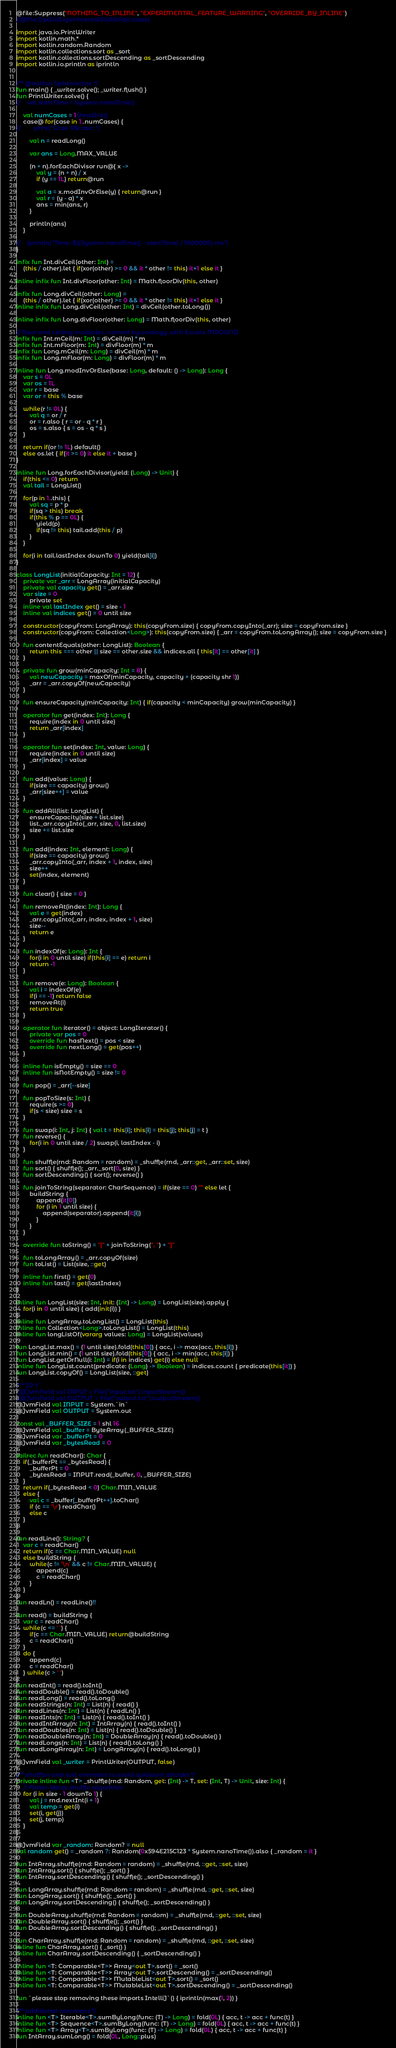Convert code to text. <code><loc_0><loc_0><loc_500><loc_500><_Kotlin_>@file:Suppress("NOTHING_TO_INLINE", "EXPERIMENTAL_FEATURE_WARNING", "OVERRIDE_BY_INLINE")
//@file:OptIn(ExperimentalStdlibApi::class)

import java.io.PrintWriter
import kotlin.math.*
import kotlin.random.Random
import kotlin.collections.sort as _sort
import kotlin.collections.sortDescending as _sortDescending
import kotlin.io.println as iprintln


/** @author Spheniscine */
fun main() { _writer.solve(); _writer.flush() }
fun PrintWriter.solve() {
//    val startTime = System.nanoTime()

    val numCases = 1//readInt()
    case@ for(case in 1..numCases) {
//        print("Case #$case: ")

        val n = readLong()

        var ans = Long.MAX_VALUE

        (n + n).forEachDivisor run@{ x ->
            val y = (n + n) / x
            if (y == 1L) return@run

            val a = x.modInvOrElse(y) { return@run }
            val r = (y - a) * x
            ans = min(ans, r)
        }

        println(ans)
    }

//    iprintln("Time: ${(System.nanoTime() - startTime) / 1000000} ms")
}

infix fun Int.divCeil(other: Int) =
    (this / other).let { if(xor(other) >= 0 && it * other != this) it+1 else it }

inline infix fun Int.divFloor(other: Int) = Math.floorDiv(this, other)

infix fun Long.divCeil(other: Long) =
    (this / other).let { if(xor(other) >= 0 && it * other != this) it+1 else it }
inline infix fun Long.divCeil(other: Int) = divCeil(other.toLong())

inline infix fun Long.divFloor(other: Long) = Math.floorDiv(this, other)

// floor and ceiling multiples, named by analogy with Excel's MROUND
infix fun Int.mCeil(m: Int) = divCeil(m) * m
infix fun Int.mFloor(m: Int) = divFloor(m) * m
infix fun Long.mCeil(m: Long) = divCeil(m) * m
infix fun Long.mFloor(m: Long) = divFloor(m) * m

inline fun Long.modInvOrElse(base: Long, default: () -> Long): Long {
    var s = 0L
    var os = 1L
    var r = base
    var or = this % base

    while(r != 0L) {
        val q = or / r
        or = r.also { r = or - q * r }
        os = s.also { s = os - q * s }
    }

    return if(or != 1L) default()
    else os.let { if(it >= 0) it else it + base }
}

inline fun Long.forEachDivisor(yield: (Long) -> Unit) {
    if(this <= 0) return
    val tail = LongList()

    for(p in 1..this) {
        val sq = p * p
        if(sq > this) break
        if(this % p == 0L) {
            yield(p)
            if(sq != this) tail.add(this / p)
        }
    }

    for(i in tail.lastIndex downTo 0) yield(tail[i])
}

class LongList(initialCapacity: Int = 12) {
    private var _arr = LongArray(initialCapacity)
    private val capacity get() = _arr.size
    var size = 0
        private set
    inline val lastIndex get() = size - 1
    inline val indices get() = 0 until size

    constructor(copyFrom: LongArray): this(copyFrom.size) { copyFrom.copyInto(_arr); size = copyFrom.size }
    constructor(copyFrom: Collection<Long>): this(copyFrom.size) { _arr = copyFrom.toLongArray(); size = copyFrom.size }

    fun contentEquals(other: LongList): Boolean {
        return this === other || size == other.size && indices.all { this[it] == other[it] }
    }

    private fun grow(minCapacity: Int = 8) {
        val newCapacity = maxOf(minCapacity, capacity + (capacity shr 1))
        _arr = _arr.copyOf(newCapacity)
    }

    fun ensureCapacity(minCapacity: Int) { if(capacity < minCapacity) grow(minCapacity) }

    operator fun get(index: Int): Long {
        require(index in 0 until size)
        return _arr[index]
    }

    operator fun set(index: Int, value: Long) {
        require(index in 0 until size)
        _arr[index] = value
    }

    fun add(value: Long) {
        if(size == capacity) grow()
        _arr[size++] = value
    }

    fun addAll(list: LongList) {
        ensureCapacity(size + list.size)
        list._arr.copyInto(_arr, size, 0, list.size)
        size += list.size
    }

    fun add(index: Int, element: Long) {
        if(size == capacity) grow()
        _arr.copyInto(_arr, index + 1, index, size)
        size++
        set(index, element)
    }

    fun clear() { size = 0 }

    fun removeAt(index: Int): Long {
        val e = get(index)
        _arr.copyInto(_arr, index, index + 1, size)
        size--
        return e
    }

    fun indexOf(e: Long): Int {
        for(i in 0 until size) if(this[i] == e) return i
        return -1
    }

    fun remove(e: Long): Boolean {
        val i = indexOf(e)
        if(i == -1) return false
        removeAt(i)
        return true
    }

    operator fun iterator() = object: LongIterator() {
        private var pos = 0
        override fun hasNext() = pos < size
        override fun nextLong() = get(pos++)
    }

    inline fun isEmpty() = size == 0
    inline fun isNotEmpty() = size != 0

    fun pop() = _arr[--size]

    fun popToSize(s: Int) {
        require(s >= 0)
        if(s < size) size = s
    }

    fun swap(i: Int, j: Int) { val t = this[i]; this[i] = this[j]; this[j] = t }
    fun reverse() {
        for(i in 0 until size / 2) swap(i, lastIndex - i)
    }

    fun shuffle(rnd: Random = random) = _shuffle(rnd, _arr::get, _arr::set, size)
    fun sort() { shuffle(); _arr._sort(0, size) }
    fun sortDescending() { sort(); reverse() }

    fun joinToString(separator: CharSequence) = if(size == 0) "" else let {
        buildString {
            append(it[0])
            for (i in 1 until size) {
                append(separator).append(it[i])
            }
        }
    }

    override fun toString() = "[" + joinToString(", ") + "]"

    fun toLongArray() = _arr.copyOf(size)
    fun toList() = List(size, ::get)

    inline fun first() = get(0)
    inline fun last() = get(lastIndex)
}

inline fun LongList(size: Int, init: (Int) -> Long) = LongList(size).apply {
    for(i in 0 until size) { add(init(i)) }
}
inline fun LongArray.toLongList() = LongList(this)
inline fun Collection<Long>.toLongList() = LongList(this)
inline fun longListOf(vararg values: Long) = LongList(values)

fun LongList.max() = (1 until size).fold(this[0]) { acc, i -> max(acc, this[i]) }
fun LongList.min() = (1 until size).fold(this[0]) { acc, i -> min(acc, this[i]) }
fun LongList.getOrNull(i: Int) = if(i in indices) get(i) else null
inline fun LongList.count(predicate: (Long) -> Boolean) = indices.count { predicate(this[it]) }
fun LongList.copyOf() = LongList(size, ::get)

/** IO */
//@JvmField val INPUT = File("input.txt").inputStream()
//@JvmField val OUTPUT = File("output.txt").outputStream()
@JvmField val INPUT = System.`in`
@JvmField val OUTPUT = System.out

const val _BUFFER_SIZE = 1 shl 16
@JvmField val _buffer = ByteArray(_BUFFER_SIZE)
@JvmField var _bufferPt = 0
@JvmField var _bytesRead = 0

tailrec fun readChar(): Char {
    if(_bufferPt == _bytesRead) {
        _bufferPt = 0
        _bytesRead = INPUT.read(_buffer, 0, _BUFFER_SIZE)
    }
    return if(_bytesRead < 0) Char.MIN_VALUE
    else {
        val c = _buffer[_bufferPt++].toChar()
        if (c == '\r') readChar()
        else c
    }
}

fun readLine(): String? {
    var c = readChar()
    return if(c == Char.MIN_VALUE) null
    else buildString {
        while(c != '\n' && c != Char.MIN_VALUE) {
            append(c)
            c = readChar()
        }
    }
}
fun readLn() = readLine()!!

fun read() = buildString {
    var c = readChar()
    while(c <= ' ') {
        if(c == Char.MIN_VALUE) return@buildString
        c = readChar()
    }
    do {
        append(c)
        c = readChar()
    } while(c > ' ')
}
fun readInt() = read().toInt()
fun readDouble() = read().toDouble()
fun readLong() = read().toLong()
fun readStrings(n: Int) = List(n) { read() }
fun readLines(n: Int) = List(n) { readLn() }
fun readInts(n: Int) = List(n) { read().toInt() }
fun readIntArray(n: Int) = IntArray(n) { read().toInt() }
fun readDoubles(n: Int) = List(n) { read().toDouble() }
fun readDoubleArray(n: Int) = DoubleArray(n) { read().toDouble() }
fun readLongs(n: Int) = List(n) { read().toLong() }
fun readLongArray(n: Int) = LongArray(n) { read().toLong() }

@JvmField val _writer = PrintWriter(OUTPUT, false)

/** shuffles and sort overrides to avoid quicksort attacks */
private inline fun <T> _shuffle(rnd: Random, get: (Int) -> T, set: (Int, T) -> Unit, size: Int) {
    // Fisher-Yates shuffle algorithm
    for (i in size - 1 downTo 1) {
        val j = rnd.nextInt(i + 1)
        val temp = get(i)
        set(i, get(j))
        set(j, temp)
    }
}

@JvmField var _random: Random? = null
val random get() = _random ?: Random(0x594E215C123 * System.nanoTime()).also { _random = it }

fun IntArray.shuffle(rnd: Random = random) = _shuffle(rnd, ::get, ::set, size)
fun IntArray.sort() { shuffle(); _sort() }
fun IntArray.sortDescending() { shuffle(); _sortDescending() }

fun LongArray.shuffle(rnd: Random = random) = _shuffle(rnd, ::get, ::set, size)
fun LongArray.sort() { shuffle(); _sort() }
fun LongArray.sortDescending() { shuffle(); _sortDescending() }

fun DoubleArray.shuffle(rnd: Random = random) = _shuffle(rnd, ::get, ::set, size)
fun DoubleArray.sort() { shuffle(); _sort() }
fun DoubleArray.sortDescending() { shuffle(); _sortDescending() }

fun CharArray.shuffle(rnd: Random = random) = _shuffle(rnd, ::get, ::set, size)
inline fun CharArray.sort() { _sort() }
inline fun CharArray.sortDescending() { _sortDescending() }

inline fun <T: Comparable<T>> Array<out T>.sort() = _sort()
inline fun <T: Comparable<T>> Array<out T>.sortDescending() = _sortDescending()
inline fun <T: Comparable<T>> MutableList<out T>.sort() = _sort()
inline fun <T: Comparable<T>> MutableList<out T>.sortDescending() = _sortDescending()

fun `please stop removing these imports IntelliJ`() { iprintln(max(1, 2)) }

/** additional commons */
inline fun <T> Iterable<T>.sumByLong(func: (T) -> Long) = fold(0L) { acc, t -> acc + func(t) }
inline fun <T> Sequence<T>.sumByLong(func: (T) -> Long) = fold(0L) { acc, t -> acc + func(t) }
inline fun <T> Array<T>.sumByLong(func: (T) -> Long) = fold(0L) { acc, t -> acc + func(t) }
fun IntArray.sumLong() = fold(0L, Long::plus)
</code> 